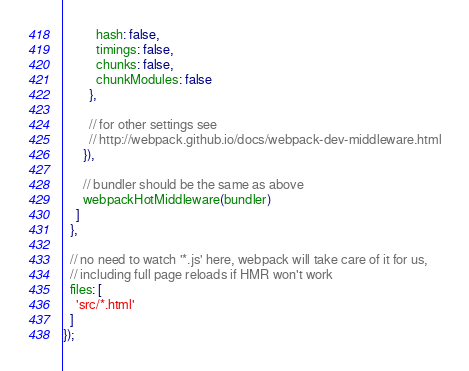Convert code to text. <code><loc_0><loc_0><loc_500><loc_500><_JavaScript_>          hash: false,
          timings: false,
          chunks: false,
          chunkModules: false
        },

        // for other settings see
        // http://webpack.github.io/docs/webpack-dev-middleware.html
      }),

      // bundler should be the same as above
      webpackHotMiddleware(bundler)
    ]
  },

  // no need to watch '*.js' here, webpack will take care of it for us,
  // including full page reloads if HMR won't work
  files: [
    'src/*.html'
  ]
});
</code> 